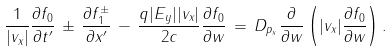Convert formula to latex. <formula><loc_0><loc_0><loc_500><loc_500>\frac { 1 } { | v _ { x } | } \frac { \partial f _ { 0 } } { \partial t ^ { \prime } } \, \pm \, \frac { \partial f ^ { \pm } _ { 1 } } { \partial x ^ { \prime } } \, - \, \frac { q | E _ { y } | | v _ { x } | } { 2 c } \frac { \partial f _ { 0 } } { \partial w } \, = \, D _ { p _ { x } } \frac { \partial } { \partial w } \left ( | v _ { x } | \frac { \partial f _ { 0 } } { \partial w } \right ) .</formula> 